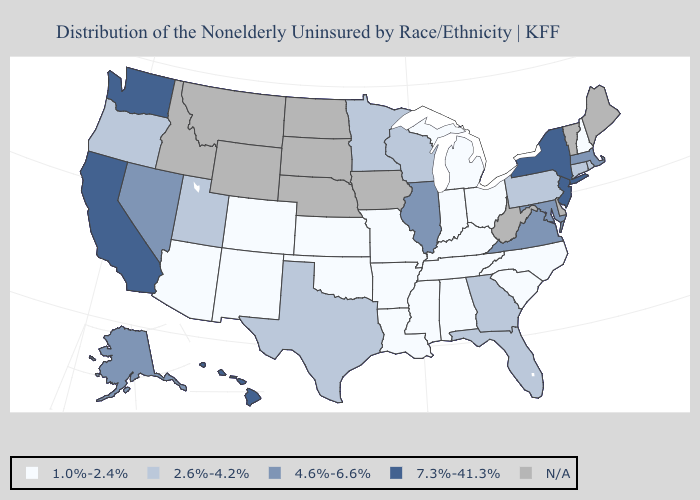Name the states that have a value in the range N/A?
Write a very short answer. Delaware, Idaho, Iowa, Maine, Montana, Nebraska, North Dakota, South Dakota, Vermont, West Virginia, Wyoming. Among the states that border South Carolina , does North Carolina have the highest value?
Give a very brief answer. No. Does Washington have the highest value in the West?
Short answer required. Yes. Which states have the lowest value in the South?
Write a very short answer. Alabama, Arkansas, Kentucky, Louisiana, Mississippi, North Carolina, Oklahoma, South Carolina, Tennessee. What is the value of California?
Quick response, please. 7.3%-41.3%. What is the lowest value in the USA?
Keep it brief. 1.0%-2.4%. Name the states that have a value in the range 2.6%-4.2%?
Keep it brief. Connecticut, Florida, Georgia, Minnesota, Oregon, Pennsylvania, Rhode Island, Texas, Utah, Wisconsin. What is the value of Iowa?
Write a very short answer. N/A. Which states have the lowest value in the Northeast?
Quick response, please. New Hampshire. Name the states that have a value in the range 2.6%-4.2%?
Be succinct. Connecticut, Florida, Georgia, Minnesota, Oregon, Pennsylvania, Rhode Island, Texas, Utah, Wisconsin. Among the states that border West Virginia , which have the lowest value?
Keep it brief. Kentucky, Ohio. Name the states that have a value in the range 2.6%-4.2%?
Concise answer only. Connecticut, Florida, Georgia, Minnesota, Oregon, Pennsylvania, Rhode Island, Texas, Utah, Wisconsin. Which states have the lowest value in the Northeast?
Quick response, please. New Hampshire. 